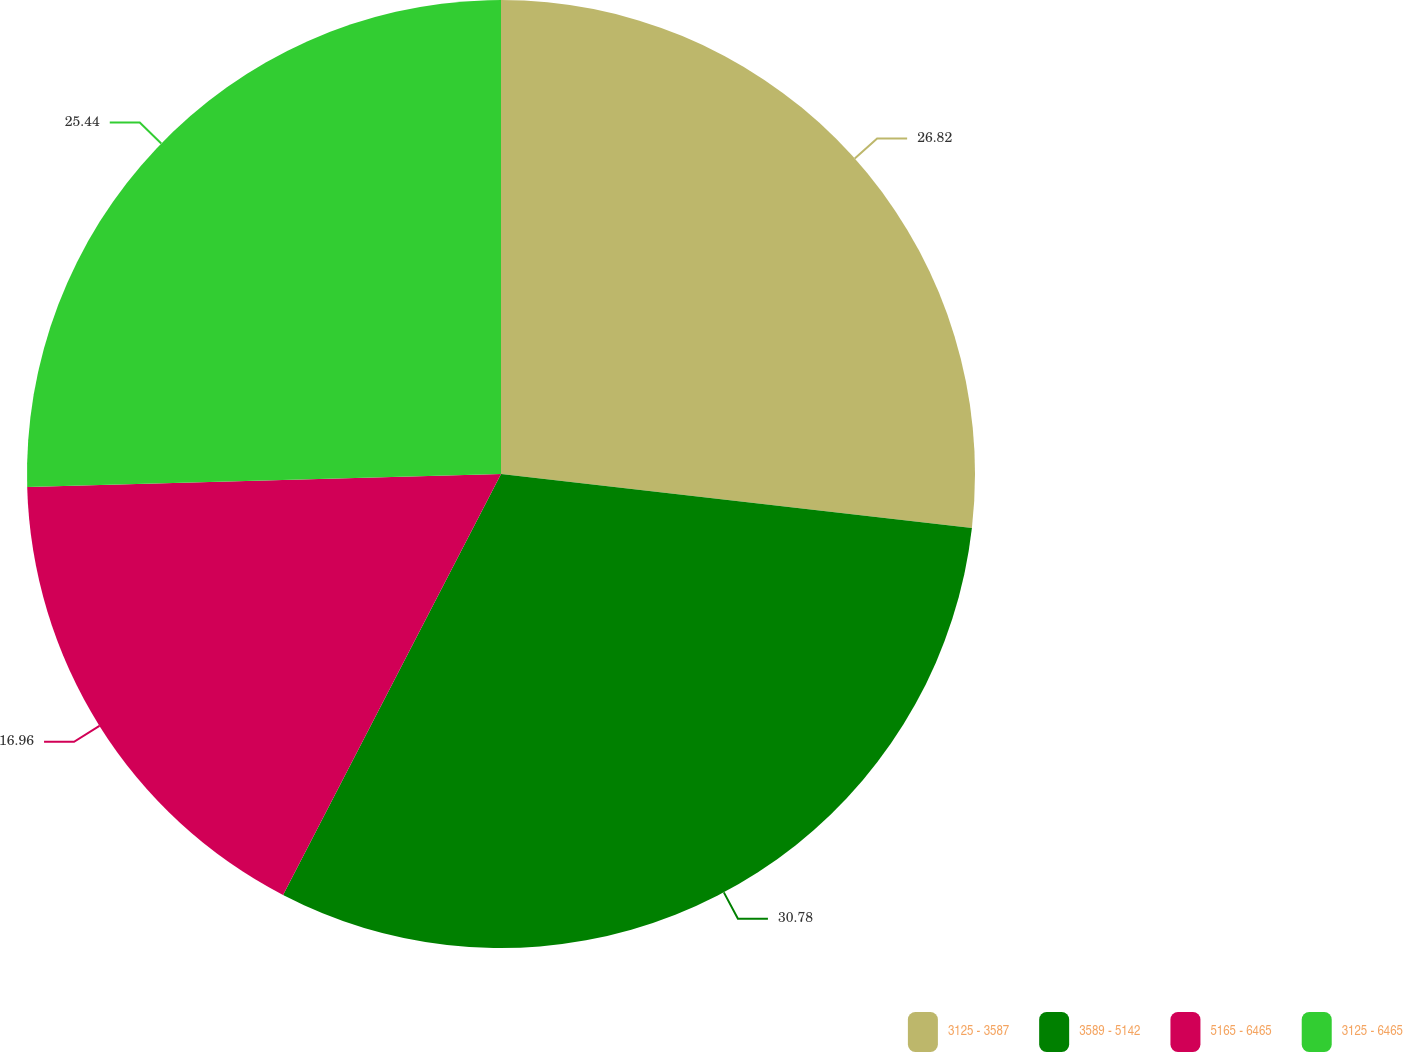Convert chart. <chart><loc_0><loc_0><loc_500><loc_500><pie_chart><fcel>3125 - 3587<fcel>3589 - 5142<fcel>5165 - 6465<fcel>3125 - 6465<nl><fcel>26.82%<fcel>30.79%<fcel>16.96%<fcel>25.44%<nl></chart> 